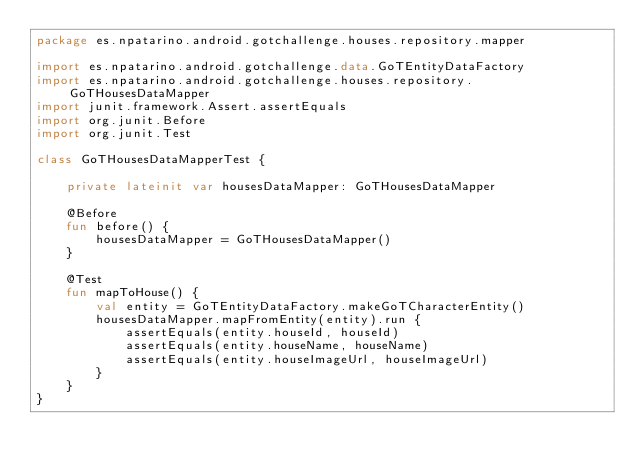Convert code to text. <code><loc_0><loc_0><loc_500><loc_500><_Kotlin_>package es.npatarino.android.gotchallenge.houses.repository.mapper

import es.npatarino.android.gotchallenge.data.GoTEntityDataFactory
import es.npatarino.android.gotchallenge.houses.repository.GoTHousesDataMapper
import junit.framework.Assert.assertEquals
import org.junit.Before
import org.junit.Test

class GoTHousesDataMapperTest {

    private lateinit var housesDataMapper: GoTHousesDataMapper

    @Before
    fun before() {
        housesDataMapper = GoTHousesDataMapper()
    }

    @Test
    fun mapToHouse() {
        val entity = GoTEntityDataFactory.makeGoTCharacterEntity()
        housesDataMapper.mapFromEntity(entity).run {
            assertEquals(entity.houseId, houseId)
            assertEquals(entity.houseName, houseName)
            assertEquals(entity.houseImageUrl, houseImageUrl)
        }
    }
}</code> 